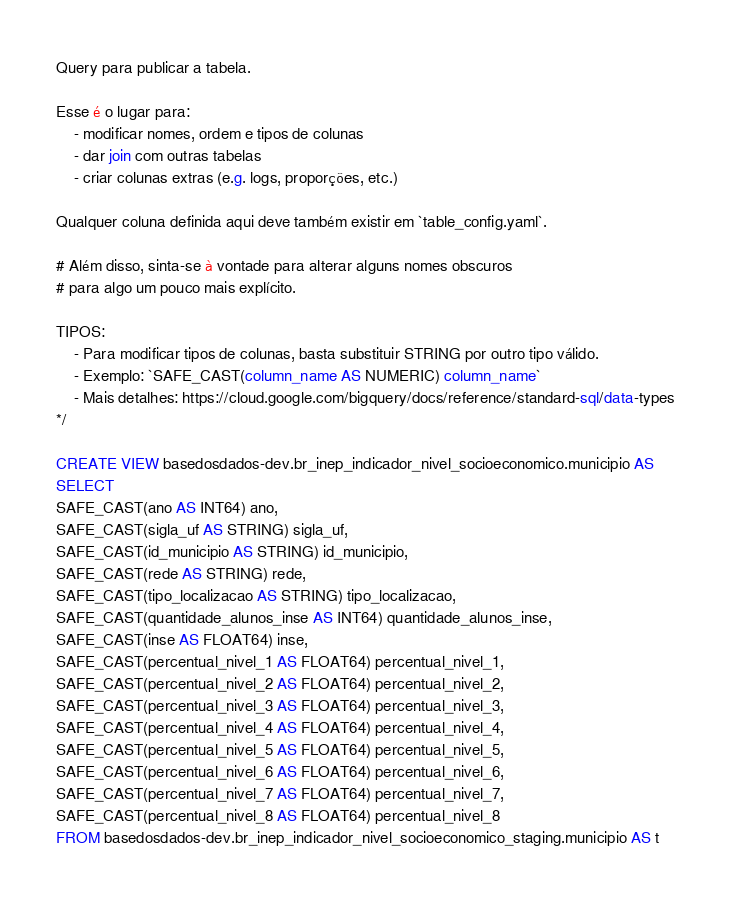Convert code to text. <code><loc_0><loc_0><loc_500><loc_500><_SQL_>Query para publicar a tabela.

Esse é o lugar para:
    - modificar nomes, ordem e tipos de colunas
    - dar join com outras tabelas
    - criar colunas extras (e.g. logs, proporções, etc.)

Qualquer coluna definida aqui deve também existir em `table_config.yaml`.

# Além disso, sinta-se à vontade para alterar alguns nomes obscuros
# para algo um pouco mais explícito.

TIPOS:
    - Para modificar tipos de colunas, basta substituir STRING por outro tipo válido.
    - Exemplo: `SAFE_CAST(column_name AS NUMERIC) column_name`
    - Mais detalhes: https://cloud.google.com/bigquery/docs/reference/standard-sql/data-types
*/

CREATE VIEW basedosdados-dev.br_inep_indicador_nivel_socioeconomico.municipio AS
SELECT 
SAFE_CAST(ano AS INT64) ano,
SAFE_CAST(sigla_uf AS STRING) sigla_uf,
SAFE_CAST(id_municipio AS STRING) id_municipio,
SAFE_CAST(rede AS STRING) rede,
SAFE_CAST(tipo_localizacao AS STRING) tipo_localizacao,
SAFE_CAST(quantidade_alunos_inse AS INT64) quantidade_alunos_inse,
SAFE_CAST(inse AS FLOAT64) inse,
SAFE_CAST(percentual_nivel_1 AS FLOAT64) percentual_nivel_1,
SAFE_CAST(percentual_nivel_2 AS FLOAT64) percentual_nivel_2,
SAFE_CAST(percentual_nivel_3 AS FLOAT64) percentual_nivel_3,
SAFE_CAST(percentual_nivel_4 AS FLOAT64) percentual_nivel_4,
SAFE_CAST(percentual_nivel_5 AS FLOAT64) percentual_nivel_5,
SAFE_CAST(percentual_nivel_6 AS FLOAT64) percentual_nivel_6,
SAFE_CAST(percentual_nivel_7 AS FLOAT64) percentual_nivel_7,
SAFE_CAST(percentual_nivel_8 AS FLOAT64) percentual_nivel_8
FROM basedosdados-dev.br_inep_indicador_nivel_socioeconomico_staging.municipio AS t</code> 